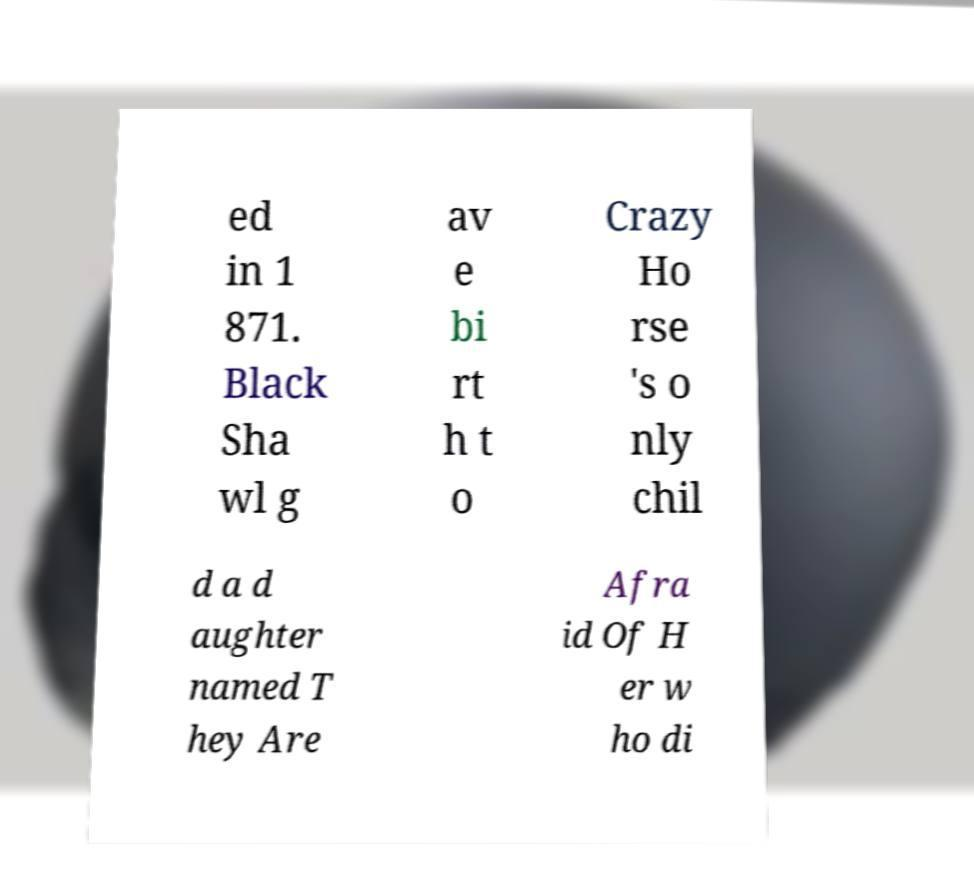Could you assist in decoding the text presented in this image and type it out clearly? ed in 1 871. Black Sha wl g av e bi rt h t o Crazy Ho rse 's o nly chil d a d aughter named T hey Are Afra id Of H er w ho di 